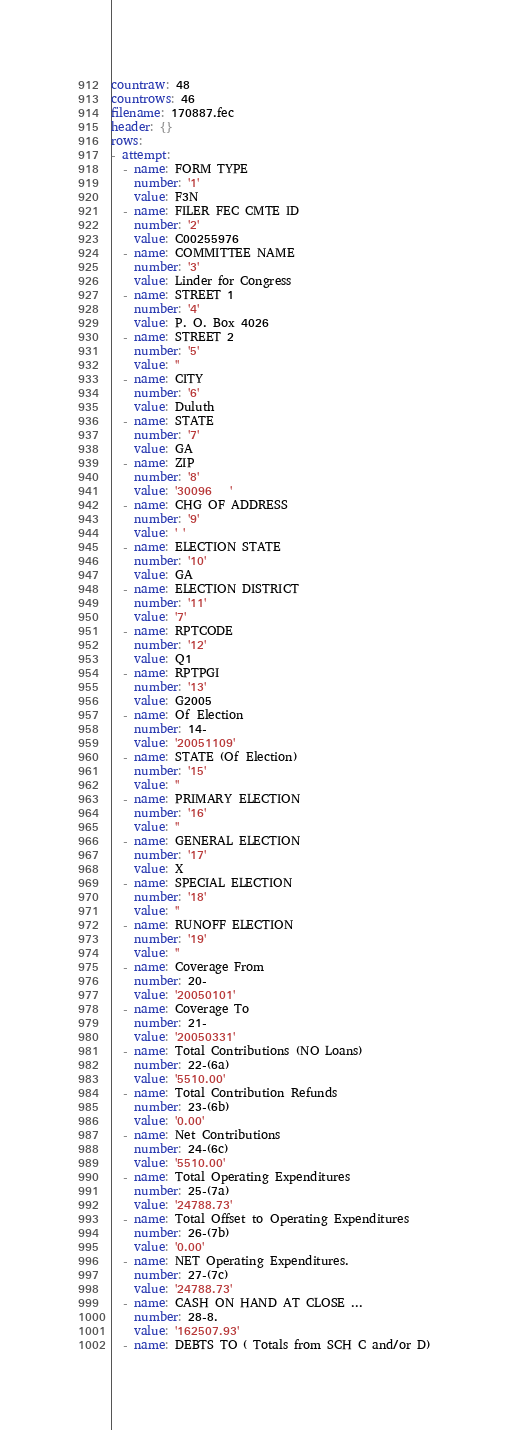Convert code to text. <code><loc_0><loc_0><loc_500><loc_500><_YAML_>countraw: 48
countrows: 46
filename: 170887.fec
header: {}
rows:
- attempt:
  - name: FORM TYPE
    number: '1'
    value: F3N
  - name: FILER FEC CMTE ID
    number: '2'
    value: C00255976
  - name: COMMITTEE NAME
    number: '3'
    value: Linder for Congress
  - name: STREET 1
    number: '4'
    value: P. O. Box 4026
  - name: STREET 2
    number: '5'
    value: ''
  - name: CITY
    number: '6'
    value: Duluth
  - name: STATE
    number: '7'
    value: GA
  - name: ZIP
    number: '8'
    value: '30096   '
  - name: CHG OF ADDRESS
    number: '9'
    value: ' '
  - name: ELECTION STATE
    number: '10'
    value: GA
  - name: ELECTION DISTRICT
    number: '11'
    value: '7'
  - name: RPTCODE
    number: '12'
    value: Q1
  - name: RPTPGI
    number: '13'
    value: G2005
  - name: Of Election
    number: 14-
    value: '20051109'
  - name: STATE (Of Election)
    number: '15'
    value: ''
  - name: PRIMARY ELECTION
    number: '16'
    value: ''
  - name: GENERAL ELECTION
    number: '17'
    value: X
  - name: SPECIAL ELECTION
    number: '18'
    value: ''
  - name: RUNOFF ELECTION
    number: '19'
    value: ''
  - name: Coverage From
    number: 20-
    value: '20050101'
  - name: Coverage To
    number: 21-
    value: '20050331'
  - name: Total Contributions (NO Loans)
    number: 22-(6a)
    value: '5510.00'
  - name: Total Contribution Refunds
    number: 23-(6b)
    value: '0.00'
  - name: Net Contributions
    number: 24-(6c)
    value: '5510.00'
  - name: Total Operating Expenditures
    number: 25-(7a)
    value: '24788.73'
  - name: Total Offset to Operating Expenditures
    number: 26-(7b)
    value: '0.00'
  - name: NET Operating Expenditures.
    number: 27-(7c)
    value: '24788.73'
  - name: CASH ON HAND AT CLOSE ...
    number: 28-8.
    value: '162507.93'
  - name: DEBTS TO ( Totals from SCH C and/or D)</code> 